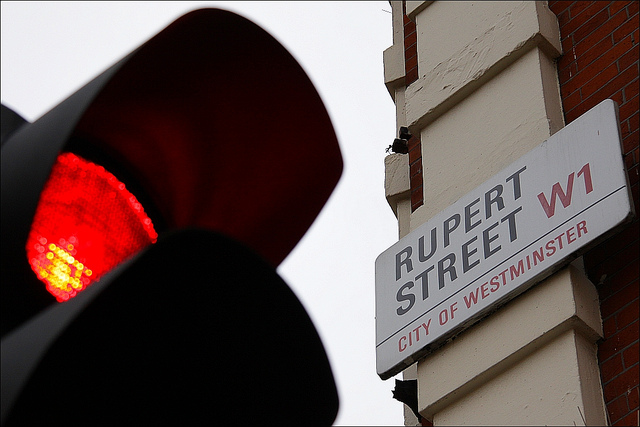Identify the text contained in this image. RUPERT STREET W1 CITY WESTINS STER OF 